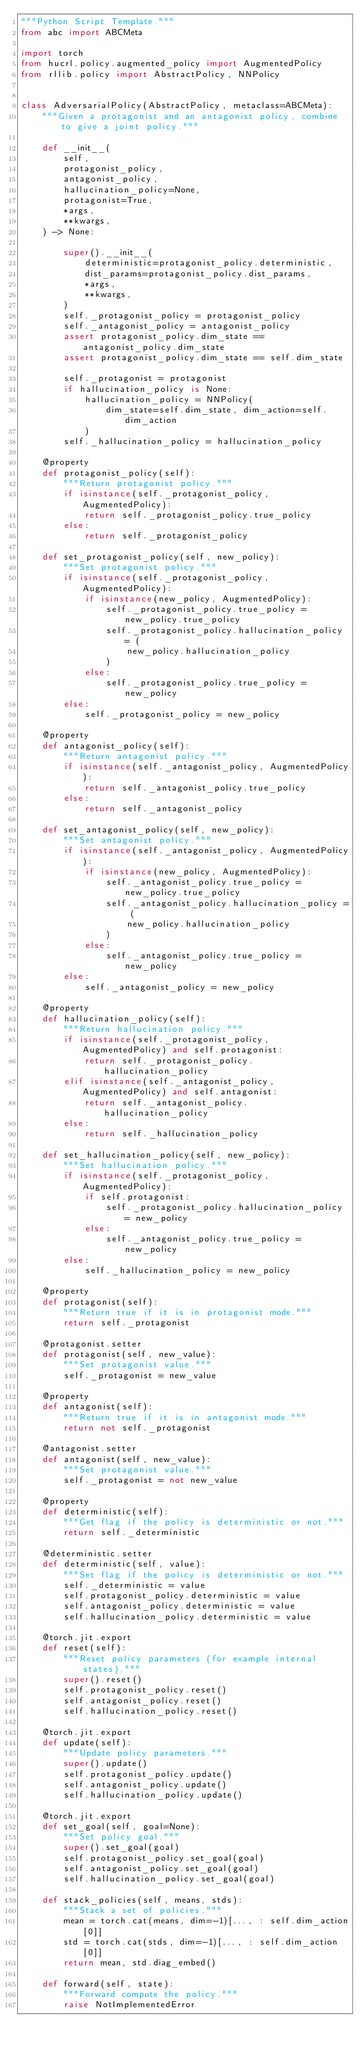<code> <loc_0><loc_0><loc_500><loc_500><_Python_>"""Python Script Template."""
from abc import ABCMeta

import torch
from hucrl.policy.augmented_policy import AugmentedPolicy
from rllib.policy import AbstractPolicy, NNPolicy


class AdversarialPolicy(AbstractPolicy, metaclass=ABCMeta):
    """Given a protagonist and an antagonist policy, combine to give a joint policy."""

    def __init__(
        self,
        protagonist_policy,
        antagonist_policy,
        hallucination_policy=None,
        protagonist=True,
        *args,
        **kwargs,
    ) -> None:

        super().__init__(
            deterministic=protagonist_policy.deterministic,
            dist_params=protagonist_policy.dist_params,
            *args,
            **kwargs,
        )
        self._protagonist_policy = protagonist_policy
        self._antagonist_policy = antagonist_policy
        assert protagonist_policy.dim_state == antagonist_policy.dim_state
        assert protagonist_policy.dim_state == self.dim_state

        self._protagonist = protagonist
        if hallucination_policy is None:
            hallucination_policy = NNPolicy(
                dim_state=self.dim_state, dim_action=self.dim_action
            )
        self._hallucination_policy = hallucination_policy

    @property
    def protagonist_policy(self):
        """Return protagonist policy."""
        if isinstance(self._protagonist_policy, AugmentedPolicy):
            return self._protagonist_policy.true_policy
        else:
            return self._protagonist_policy

    def set_protagonist_policy(self, new_policy):
        """Set protagonist policy."""
        if isinstance(self._protagonist_policy, AugmentedPolicy):
            if isinstance(new_policy, AugmentedPolicy):
                self._protagonist_policy.true_policy = new_policy.true_policy
                self._protagonist_policy.hallucination_policy = (
                    new_policy.hallucination_policy
                )
            else:
                self._protagonist_policy.true_policy = new_policy
        else:
            self._protagonist_policy = new_policy

    @property
    def antagonist_policy(self):
        """Return antagonist policy."""
        if isinstance(self._antagonist_policy, AugmentedPolicy):
            return self._antagonist_policy.true_policy
        else:
            return self._antagonist_policy

    def set_antagonist_policy(self, new_policy):
        """Set antagonist policy."""
        if isinstance(self._antagonist_policy, AugmentedPolicy):
            if isinstance(new_policy, AugmentedPolicy):
                self._antagonist_policy.true_policy = new_policy.true_policy
                self._antagonist_policy.hallucination_policy = (
                    new_policy.hallucination_policy
                )
            else:
                self._antagonist_policy.true_policy = new_policy
        else:
            self._antagonist_policy = new_policy

    @property
    def hallucination_policy(self):
        """Return hallucination policy."""
        if isinstance(self._protagonist_policy, AugmentedPolicy) and self.protagonist:
            return self._protagonist_policy.hallucination_policy
        elif isinstance(self._antagonist_policy, AugmentedPolicy) and self.antagonist:
            return self._antagonist_policy.hallucination_policy
        else:
            return self._hallucination_policy

    def set_hallucination_policy(self, new_policy):
        """Set hallucination policy."""
        if isinstance(self._protagonist_policy, AugmentedPolicy):
            if self.protagonist:
                self._protagonist_policy.hallucination_policy = new_policy
            else:
                self._antagonist_policy.true_policy = new_policy
        else:
            self._hallucination_policy = new_policy

    @property
    def protagonist(self):
        """Return true if it is in protagonist mode."""
        return self._protagonist

    @protagonist.setter
    def protagonist(self, new_value):
        """Set protagonist value."""
        self._protagonist = new_value

    @property
    def antagonist(self):
        """Return true if it is in antagonist mode."""
        return not self._protagonist

    @antagonist.setter
    def antagonist(self, new_value):
        """Set protagonist value."""
        self._protagonist = not new_value

    @property
    def deterministic(self):
        """Get flag if the policy is deterministic or not."""
        return self._deterministic

    @deterministic.setter
    def deterministic(self, value):
        """Set flag if the policy is deterministic or not."""
        self._deterministic = value
        self.protagonist_policy.deterministic = value
        self.antagonist_policy.deterministic = value
        self.hallucination_policy.deterministic = value

    @torch.jit.export
    def reset(self):
        """Reset policy parameters (for example internal states)."""
        super().reset()
        self.protagonist_policy.reset()
        self.antagonist_policy.reset()
        self.hallucination_policy.reset()

    @torch.jit.export
    def update(self):
        """Update policy parameters."""
        super().update()
        self.protagonist_policy.update()
        self.antagonist_policy.update()
        self.hallucination_policy.update()

    @torch.jit.export
    def set_goal(self, goal=None):
        """Set policy goal."""
        super().set_goal(goal)
        self.protagonist_policy.set_goal(goal)
        self.antagonist_policy.set_goal(goal)
        self.hallucination_policy.set_goal(goal)

    def stack_policies(self, means, stds):
        """Stack a set of policies."""
        mean = torch.cat(means, dim=-1)[..., : self.dim_action[0]]
        std = torch.cat(stds, dim=-1)[..., : self.dim_action[0]]
        return mean, std.diag_embed()

    def forward(self, state):
        """Forward compute the policy."""
        raise NotImplementedError
</code> 